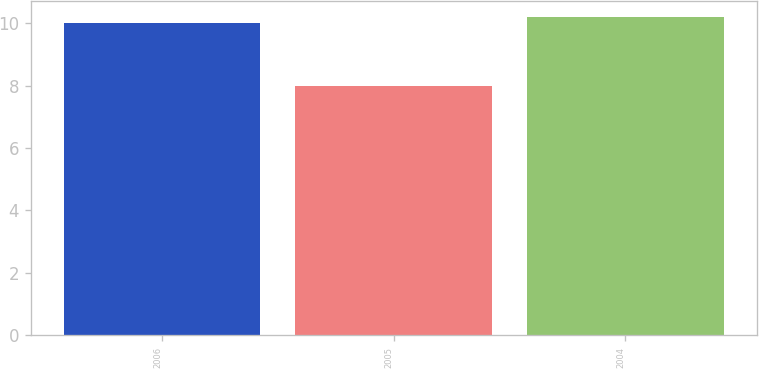<chart> <loc_0><loc_0><loc_500><loc_500><bar_chart><fcel>2006<fcel>2005<fcel>2004<nl><fcel>10<fcel>8<fcel>10.2<nl></chart> 